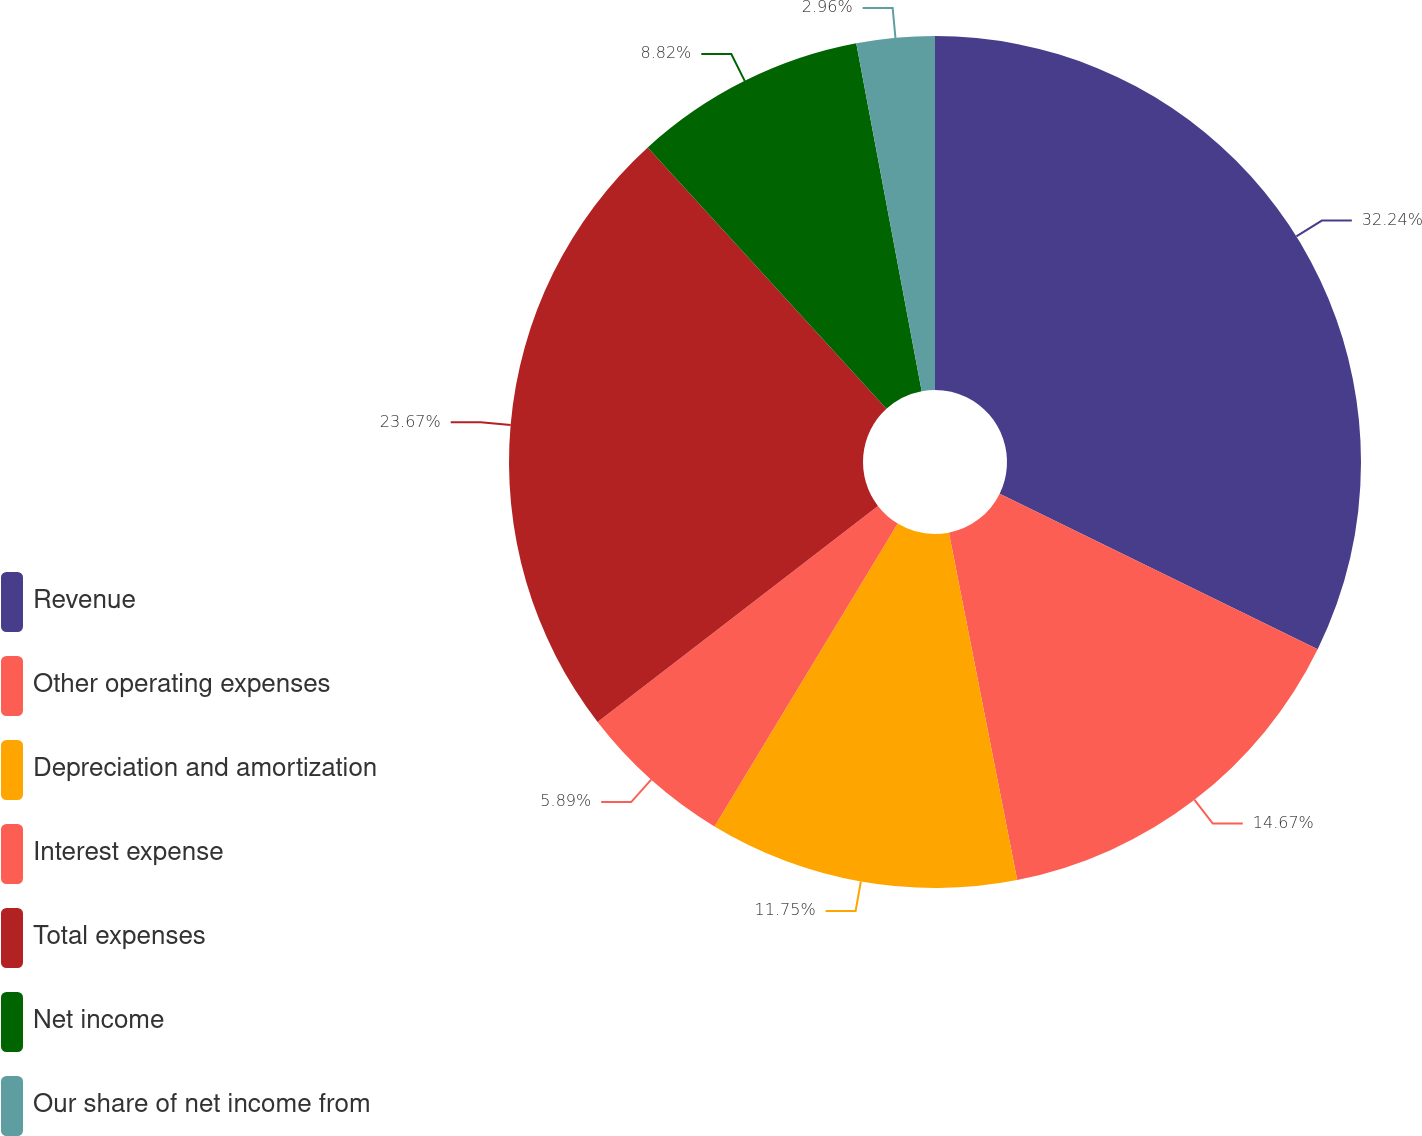Convert chart. <chart><loc_0><loc_0><loc_500><loc_500><pie_chart><fcel>Revenue<fcel>Other operating expenses<fcel>Depreciation and amortization<fcel>Interest expense<fcel>Total expenses<fcel>Net income<fcel>Our share of net income from<nl><fcel>32.24%<fcel>14.67%<fcel>11.75%<fcel>5.89%<fcel>23.67%<fcel>8.82%<fcel>2.96%<nl></chart> 